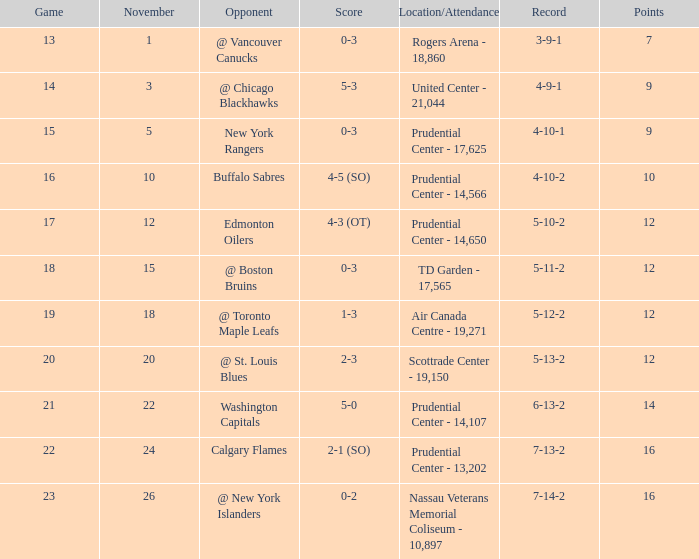What is the track record for score 1-3? 5-12-2. 